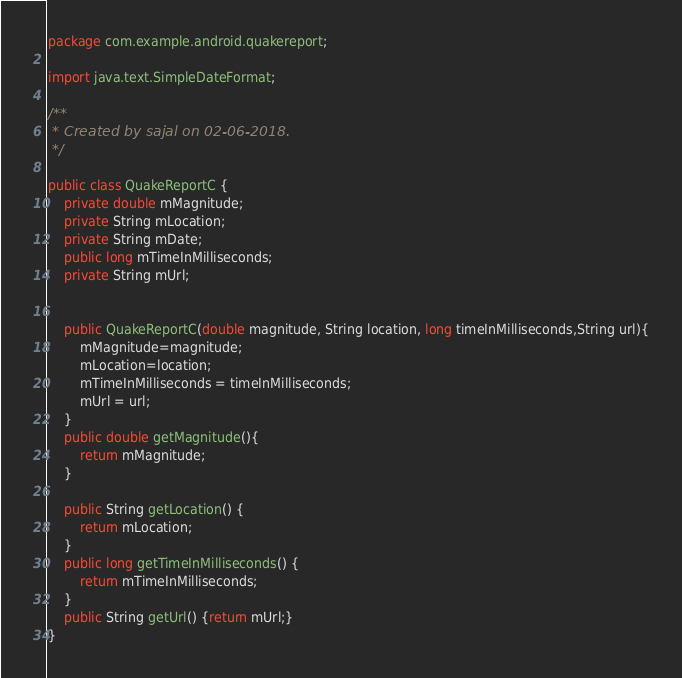<code> <loc_0><loc_0><loc_500><loc_500><_Java_>package com.example.android.quakereport;

import java.text.SimpleDateFormat;

/**
 * Created by sajal on 02-06-2018.
 */

public class QuakeReportC {
    private double mMagnitude;
    private String mLocation;
    private String mDate;
    public long mTimeInMilliseconds;
    private String mUrl;


    public QuakeReportC(double magnitude, String location, long timeInMilliseconds,String url){
        mMagnitude=magnitude;
        mLocation=location;
        mTimeInMilliseconds = timeInMilliseconds;
        mUrl = url;
    }
    public double getMagnitude(){
        return mMagnitude;
    }

    public String getLocation() {
        return mLocation;
    }
    public long getTimeInMilliseconds() {
        return mTimeInMilliseconds;
    }
    public String getUrl() {return mUrl;}
}
</code> 